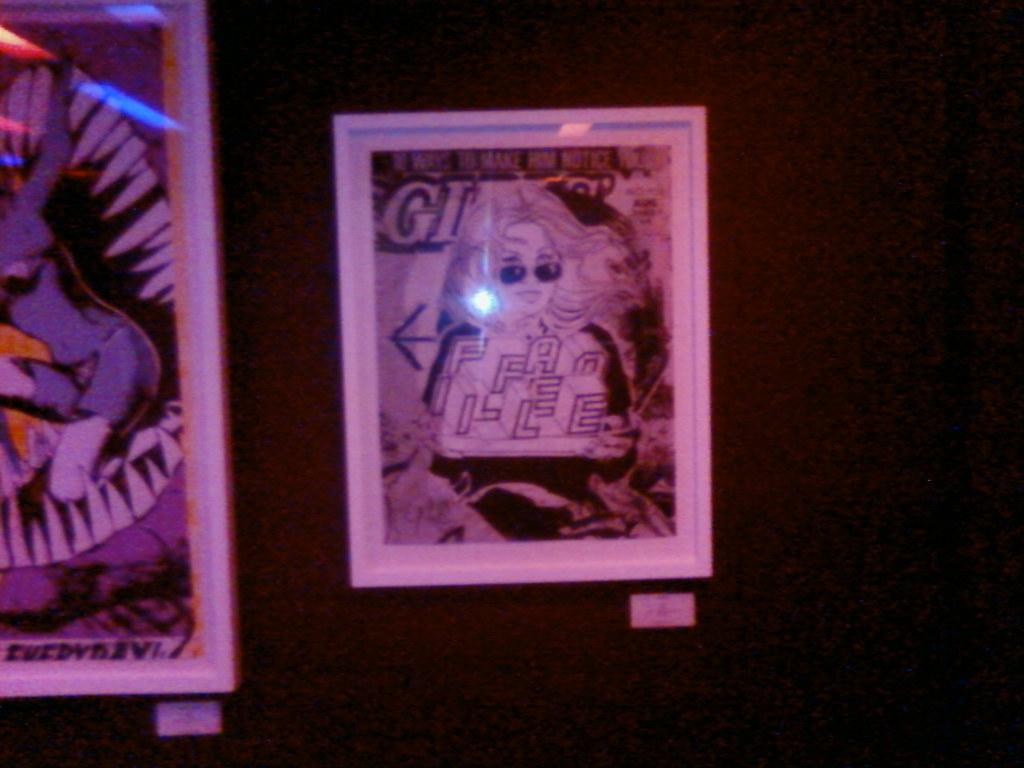<image>
Create a compact narrative representing the image presented. A framed comic cover has the tag line "Make Him Notice" on the top of it. 